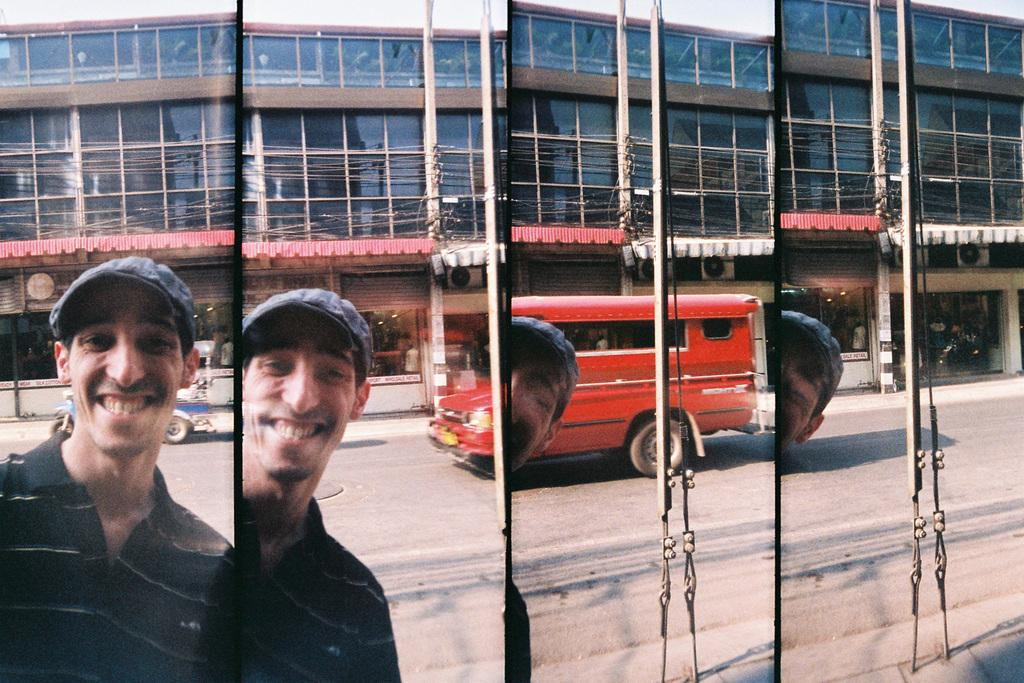What type of artwork is the image? The image is a collage. Can you describe the man in the image? There is a man in the image, and he is smiling. What can be seen in the background of the image? There is a road and buildings visible in the background of the image. What is happening on the road in the image? There are vehicles on the road in the image. What book is the man reading in the image? There is no book present in the image; the man is simply smiling. What action is the man performing in the image? The man is not performing any specific action in the image; he is just smiling. 